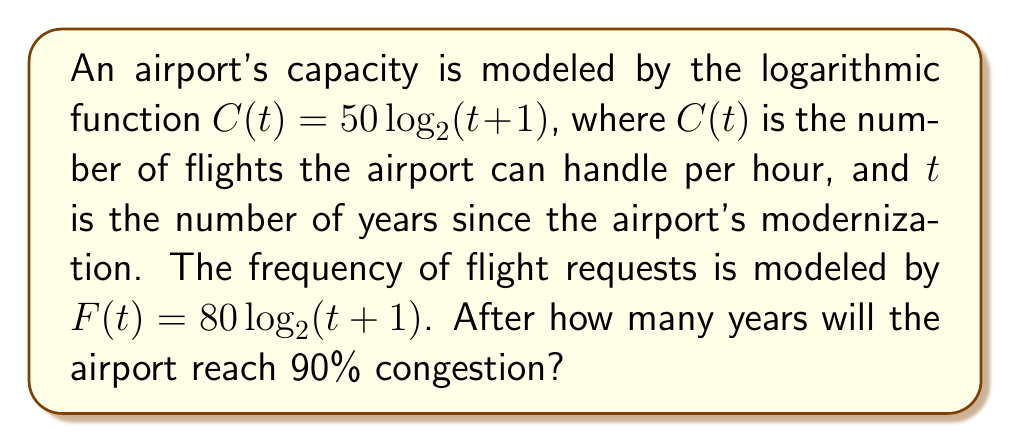Provide a solution to this math problem. To solve this problem, we'll follow these steps:

1) Define congestion as the ratio of flight requests to airport capacity:

   Congestion = $\frac{F(t)}{C(t)} \times 100\%$

2) We're looking for 90% congestion, so we set up the equation:

   $\frac{F(t)}{C(t)} = 0.9$

3) Substitute the given functions:

   $\frac{80 \log_2(t+1)}{50 \log_2(t+1)} = 0.9$

4) Simplify:

   $\frac{8}{5} = 0.9$

5) This equation is true for all $t$, meaning the congestion level is constant at 80/50 = 1.6, or 160%.

6) Since the congestion is always above 90%, we need to find when it first reaches this level.

7) The airport reaches 90% congestion immediately upon modernization (at $t=0$):

   $\frac{F(0)}{C(0)} = \frac{80 \log_2(0+1)}{50 \log_2(0+1)} = \frac{80 \cdot 0}{50 \cdot 0} = \frac{8}{5} = 1.6 = 160\%$

Therefore, the airport reaches 90% congestion after 0 years.
Answer: 0 years 